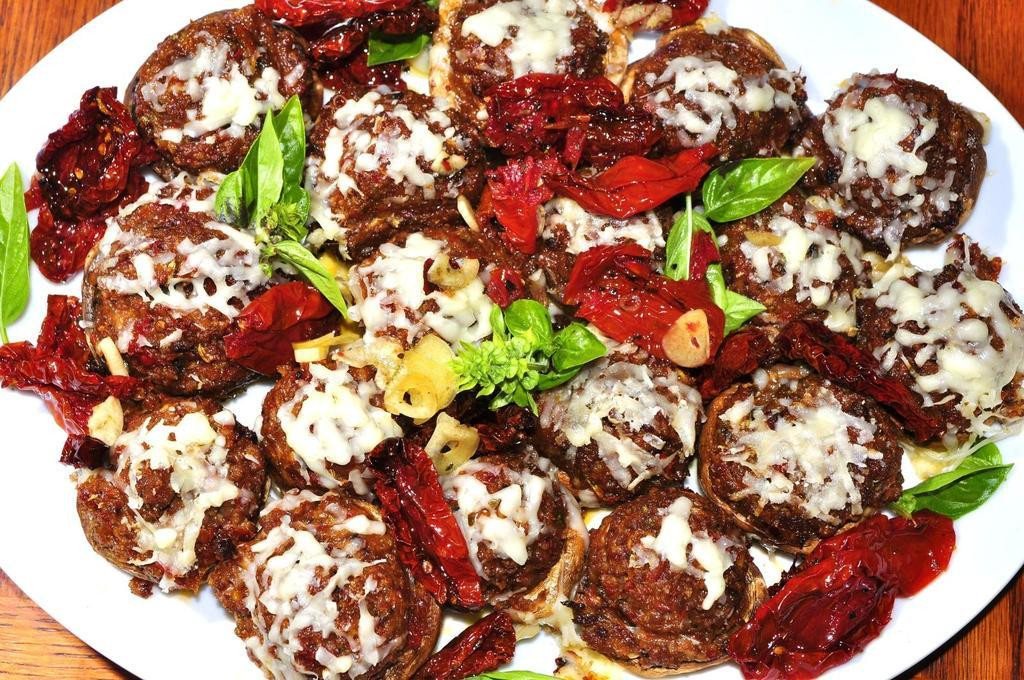What is on the plate in the image? There are food items on a plate in the image. What is the color of the plate? The plate is white in color. How many ladybugs are crawling on the ship in the image? There is no ship or ladybugs present in the image. What type of love is being expressed in the image? There is no indication of love or any emotion being expressed in the image, as it only features a plate with food items and a white plate. 